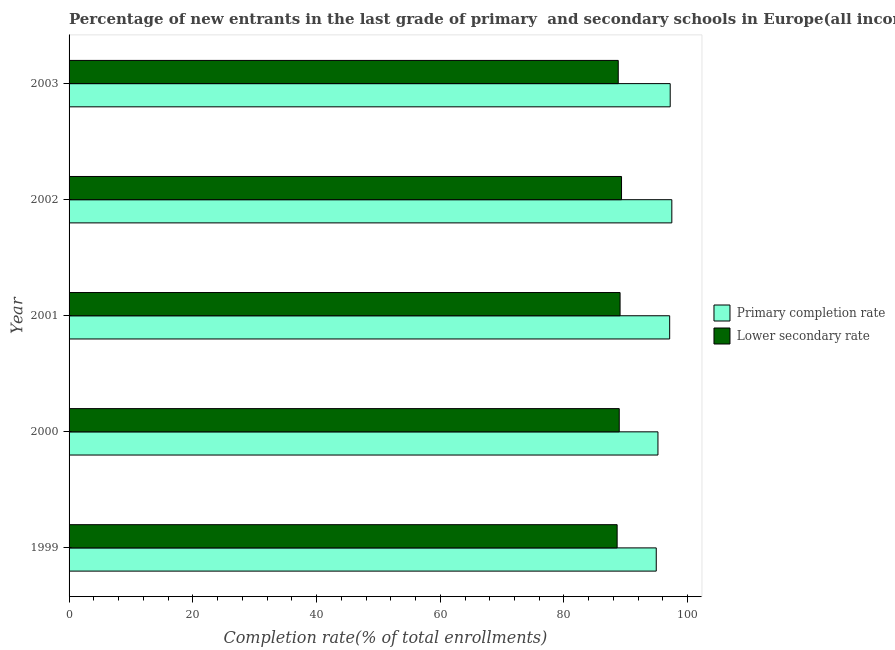How many different coloured bars are there?
Keep it short and to the point. 2. How many bars are there on the 1st tick from the top?
Make the answer very short. 2. In how many cases, is the number of bars for a given year not equal to the number of legend labels?
Your response must be concise. 0. What is the completion rate in primary schools in 2002?
Your response must be concise. 97.43. Across all years, what is the maximum completion rate in secondary schools?
Offer a very short reply. 89.3. Across all years, what is the minimum completion rate in primary schools?
Make the answer very short. 94.91. In which year was the completion rate in primary schools maximum?
Provide a succinct answer. 2002. In which year was the completion rate in primary schools minimum?
Your answer should be very brief. 1999. What is the total completion rate in primary schools in the graph?
Ensure brevity in your answer.  481.78. What is the difference between the completion rate in secondary schools in 1999 and that in 2000?
Your answer should be compact. -0.34. What is the difference between the completion rate in primary schools in 2002 and the completion rate in secondary schools in 2001?
Keep it short and to the point. 8.37. What is the average completion rate in secondary schools per year?
Provide a short and direct response. 88.93. In the year 2002, what is the difference between the completion rate in secondary schools and completion rate in primary schools?
Ensure brevity in your answer.  -8.13. In how many years, is the completion rate in primary schools greater than 64 %?
Keep it short and to the point. 5. Is the completion rate in primary schools in 2002 less than that in 2003?
Keep it short and to the point. No. What is the difference between the highest and the second highest completion rate in primary schools?
Your answer should be compact. 0.26. What is the difference between the highest and the lowest completion rate in primary schools?
Your answer should be compact. 2.52. What does the 1st bar from the top in 2000 represents?
Your answer should be compact. Lower secondary rate. What does the 2nd bar from the bottom in 1999 represents?
Give a very brief answer. Lower secondary rate. How many bars are there?
Give a very brief answer. 10. What is the difference between two consecutive major ticks on the X-axis?
Keep it short and to the point. 20. Are the values on the major ticks of X-axis written in scientific E-notation?
Make the answer very short. No. Does the graph contain any zero values?
Offer a terse response. No. Where does the legend appear in the graph?
Your answer should be compact. Center right. How are the legend labels stacked?
Provide a short and direct response. Vertical. What is the title of the graph?
Provide a short and direct response. Percentage of new entrants in the last grade of primary  and secondary schools in Europe(all income levels). What is the label or title of the X-axis?
Give a very brief answer. Completion rate(% of total enrollments). What is the label or title of the Y-axis?
Give a very brief answer. Year. What is the Completion rate(% of total enrollments) in Primary completion rate in 1999?
Your answer should be very brief. 94.91. What is the Completion rate(% of total enrollments) in Lower secondary rate in 1999?
Provide a short and direct response. 88.59. What is the Completion rate(% of total enrollments) in Primary completion rate in 2000?
Keep it short and to the point. 95.19. What is the Completion rate(% of total enrollments) in Lower secondary rate in 2000?
Give a very brief answer. 88.93. What is the Completion rate(% of total enrollments) of Primary completion rate in 2001?
Your response must be concise. 97.08. What is the Completion rate(% of total enrollments) in Lower secondary rate in 2001?
Ensure brevity in your answer.  89.06. What is the Completion rate(% of total enrollments) of Primary completion rate in 2002?
Give a very brief answer. 97.43. What is the Completion rate(% of total enrollments) in Lower secondary rate in 2002?
Your answer should be very brief. 89.3. What is the Completion rate(% of total enrollments) in Primary completion rate in 2003?
Provide a short and direct response. 97.17. What is the Completion rate(% of total enrollments) in Lower secondary rate in 2003?
Provide a short and direct response. 88.77. Across all years, what is the maximum Completion rate(% of total enrollments) of Primary completion rate?
Make the answer very short. 97.43. Across all years, what is the maximum Completion rate(% of total enrollments) in Lower secondary rate?
Provide a short and direct response. 89.3. Across all years, what is the minimum Completion rate(% of total enrollments) in Primary completion rate?
Provide a short and direct response. 94.91. Across all years, what is the minimum Completion rate(% of total enrollments) in Lower secondary rate?
Ensure brevity in your answer.  88.59. What is the total Completion rate(% of total enrollments) in Primary completion rate in the graph?
Make the answer very short. 481.78. What is the total Completion rate(% of total enrollments) of Lower secondary rate in the graph?
Your answer should be compact. 444.66. What is the difference between the Completion rate(% of total enrollments) of Primary completion rate in 1999 and that in 2000?
Provide a short and direct response. -0.28. What is the difference between the Completion rate(% of total enrollments) of Lower secondary rate in 1999 and that in 2000?
Keep it short and to the point. -0.34. What is the difference between the Completion rate(% of total enrollments) of Primary completion rate in 1999 and that in 2001?
Offer a terse response. -2.17. What is the difference between the Completion rate(% of total enrollments) of Lower secondary rate in 1999 and that in 2001?
Your answer should be compact. -0.47. What is the difference between the Completion rate(% of total enrollments) in Primary completion rate in 1999 and that in 2002?
Make the answer very short. -2.52. What is the difference between the Completion rate(% of total enrollments) of Lower secondary rate in 1999 and that in 2002?
Provide a succinct answer. -0.71. What is the difference between the Completion rate(% of total enrollments) in Primary completion rate in 1999 and that in 2003?
Offer a very short reply. -2.26. What is the difference between the Completion rate(% of total enrollments) in Lower secondary rate in 1999 and that in 2003?
Your answer should be very brief. -0.18. What is the difference between the Completion rate(% of total enrollments) of Primary completion rate in 2000 and that in 2001?
Provide a short and direct response. -1.89. What is the difference between the Completion rate(% of total enrollments) of Lower secondary rate in 2000 and that in 2001?
Ensure brevity in your answer.  -0.13. What is the difference between the Completion rate(% of total enrollments) in Primary completion rate in 2000 and that in 2002?
Give a very brief answer. -2.24. What is the difference between the Completion rate(% of total enrollments) of Lower secondary rate in 2000 and that in 2002?
Make the answer very short. -0.37. What is the difference between the Completion rate(% of total enrollments) of Primary completion rate in 2000 and that in 2003?
Provide a short and direct response. -1.98. What is the difference between the Completion rate(% of total enrollments) in Lower secondary rate in 2000 and that in 2003?
Provide a succinct answer. 0.16. What is the difference between the Completion rate(% of total enrollments) of Primary completion rate in 2001 and that in 2002?
Offer a very short reply. -0.35. What is the difference between the Completion rate(% of total enrollments) of Lower secondary rate in 2001 and that in 2002?
Your answer should be compact. -0.24. What is the difference between the Completion rate(% of total enrollments) in Primary completion rate in 2001 and that in 2003?
Give a very brief answer. -0.09. What is the difference between the Completion rate(% of total enrollments) of Lower secondary rate in 2001 and that in 2003?
Your answer should be compact. 0.3. What is the difference between the Completion rate(% of total enrollments) of Primary completion rate in 2002 and that in 2003?
Your response must be concise. 0.26. What is the difference between the Completion rate(% of total enrollments) of Lower secondary rate in 2002 and that in 2003?
Ensure brevity in your answer.  0.53. What is the difference between the Completion rate(% of total enrollments) of Primary completion rate in 1999 and the Completion rate(% of total enrollments) of Lower secondary rate in 2000?
Keep it short and to the point. 5.98. What is the difference between the Completion rate(% of total enrollments) of Primary completion rate in 1999 and the Completion rate(% of total enrollments) of Lower secondary rate in 2001?
Provide a succinct answer. 5.85. What is the difference between the Completion rate(% of total enrollments) in Primary completion rate in 1999 and the Completion rate(% of total enrollments) in Lower secondary rate in 2002?
Your answer should be compact. 5.61. What is the difference between the Completion rate(% of total enrollments) in Primary completion rate in 1999 and the Completion rate(% of total enrollments) in Lower secondary rate in 2003?
Make the answer very short. 6.14. What is the difference between the Completion rate(% of total enrollments) in Primary completion rate in 2000 and the Completion rate(% of total enrollments) in Lower secondary rate in 2001?
Provide a succinct answer. 6.12. What is the difference between the Completion rate(% of total enrollments) of Primary completion rate in 2000 and the Completion rate(% of total enrollments) of Lower secondary rate in 2002?
Make the answer very short. 5.89. What is the difference between the Completion rate(% of total enrollments) in Primary completion rate in 2000 and the Completion rate(% of total enrollments) in Lower secondary rate in 2003?
Ensure brevity in your answer.  6.42. What is the difference between the Completion rate(% of total enrollments) in Primary completion rate in 2001 and the Completion rate(% of total enrollments) in Lower secondary rate in 2002?
Your answer should be very brief. 7.78. What is the difference between the Completion rate(% of total enrollments) in Primary completion rate in 2001 and the Completion rate(% of total enrollments) in Lower secondary rate in 2003?
Ensure brevity in your answer.  8.31. What is the difference between the Completion rate(% of total enrollments) of Primary completion rate in 2002 and the Completion rate(% of total enrollments) of Lower secondary rate in 2003?
Your answer should be very brief. 8.66. What is the average Completion rate(% of total enrollments) in Primary completion rate per year?
Provide a succinct answer. 96.36. What is the average Completion rate(% of total enrollments) in Lower secondary rate per year?
Ensure brevity in your answer.  88.93. In the year 1999, what is the difference between the Completion rate(% of total enrollments) of Primary completion rate and Completion rate(% of total enrollments) of Lower secondary rate?
Make the answer very short. 6.32. In the year 2000, what is the difference between the Completion rate(% of total enrollments) of Primary completion rate and Completion rate(% of total enrollments) of Lower secondary rate?
Keep it short and to the point. 6.26. In the year 2001, what is the difference between the Completion rate(% of total enrollments) in Primary completion rate and Completion rate(% of total enrollments) in Lower secondary rate?
Provide a succinct answer. 8.02. In the year 2002, what is the difference between the Completion rate(% of total enrollments) of Primary completion rate and Completion rate(% of total enrollments) of Lower secondary rate?
Give a very brief answer. 8.13. In the year 2003, what is the difference between the Completion rate(% of total enrollments) of Primary completion rate and Completion rate(% of total enrollments) of Lower secondary rate?
Give a very brief answer. 8.4. What is the ratio of the Completion rate(% of total enrollments) of Primary completion rate in 1999 to that in 2000?
Provide a short and direct response. 1. What is the ratio of the Completion rate(% of total enrollments) in Lower secondary rate in 1999 to that in 2000?
Your answer should be compact. 1. What is the ratio of the Completion rate(% of total enrollments) in Primary completion rate in 1999 to that in 2001?
Give a very brief answer. 0.98. What is the ratio of the Completion rate(% of total enrollments) of Primary completion rate in 1999 to that in 2002?
Give a very brief answer. 0.97. What is the ratio of the Completion rate(% of total enrollments) in Lower secondary rate in 1999 to that in 2002?
Provide a succinct answer. 0.99. What is the ratio of the Completion rate(% of total enrollments) in Primary completion rate in 1999 to that in 2003?
Provide a short and direct response. 0.98. What is the ratio of the Completion rate(% of total enrollments) of Primary completion rate in 2000 to that in 2001?
Ensure brevity in your answer.  0.98. What is the ratio of the Completion rate(% of total enrollments) in Primary completion rate in 2000 to that in 2002?
Provide a succinct answer. 0.98. What is the ratio of the Completion rate(% of total enrollments) in Lower secondary rate in 2000 to that in 2002?
Offer a terse response. 1. What is the ratio of the Completion rate(% of total enrollments) in Primary completion rate in 2000 to that in 2003?
Ensure brevity in your answer.  0.98. What is the ratio of the Completion rate(% of total enrollments) in Primary completion rate in 2001 to that in 2003?
Your answer should be compact. 1. What is the difference between the highest and the second highest Completion rate(% of total enrollments) in Primary completion rate?
Your answer should be very brief. 0.26. What is the difference between the highest and the second highest Completion rate(% of total enrollments) in Lower secondary rate?
Provide a short and direct response. 0.24. What is the difference between the highest and the lowest Completion rate(% of total enrollments) in Primary completion rate?
Your response must be concise. 2.52. What is the difference between the highest and the lowest Completion rate(% of total enrollments) in Lower secondary rate?
Offer a terse response. 0.71. 